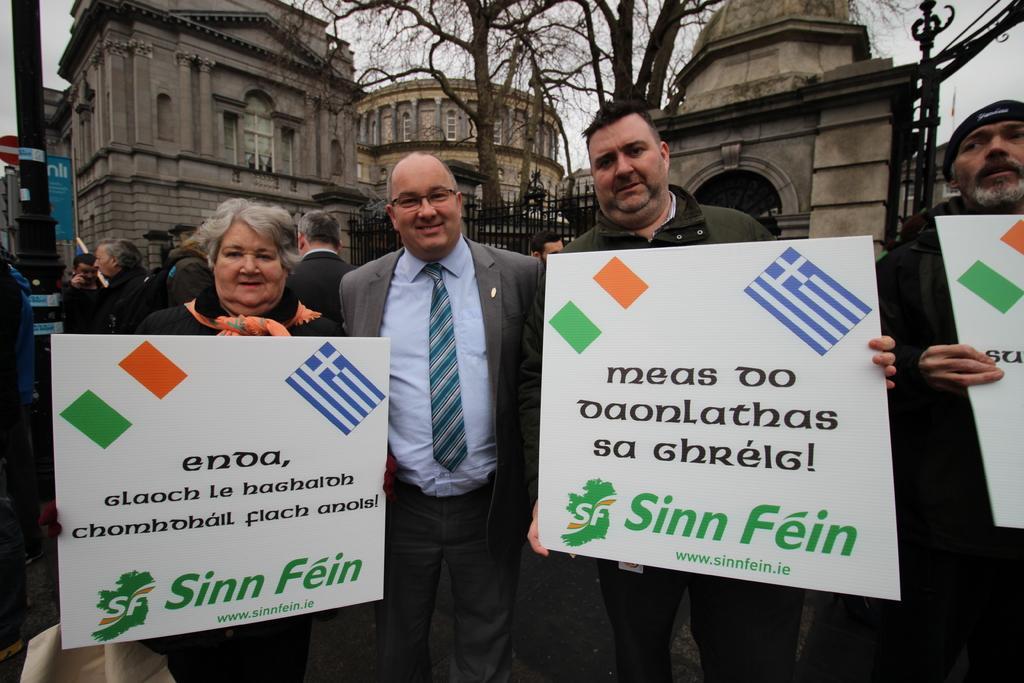Can you describe this image briefly? In the foreground of this image, there are persons standing and holding banners. In the background, there are persons, a pole, buildings, trees, fencing and the sky. 